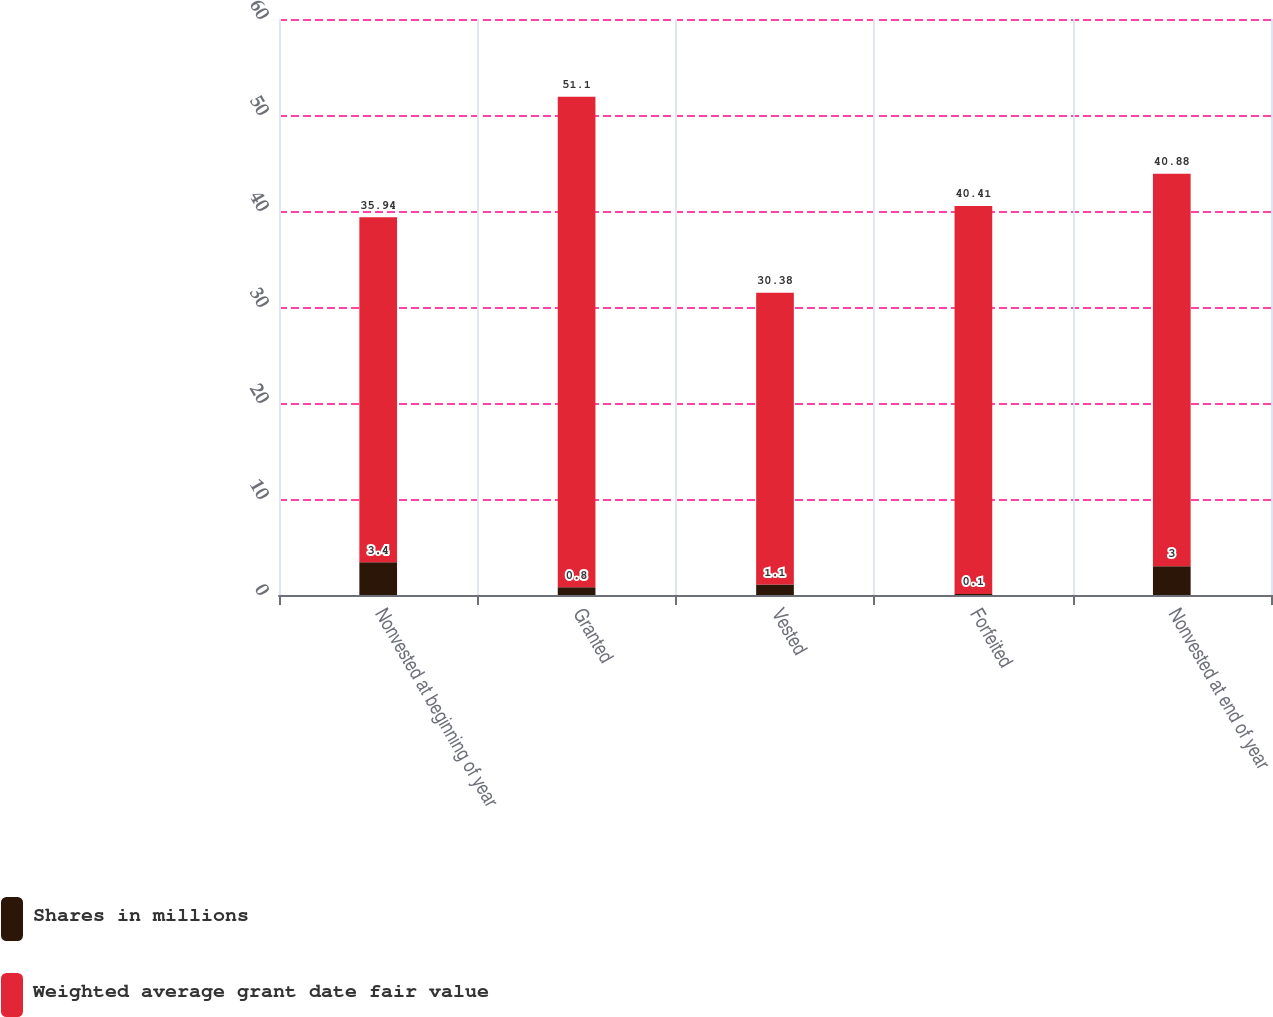<chart> <loc_0><loc_0><loc_500><loc_500><stacked_bar_chart><ecel><fcel>Nonvested at beginning of year<fcel>Granted<fcel>Vested<fcel>Forfeited<fcel>Nonvested at end of year<nl><fcel>Shares in millions<fcel>3.4<fcel>0.8<fcel>1.1<fcel>0.1<fcel>3<nl><fcel>Weighted average grant date fair value<fcel>35.94<fcel>51.1<fcel>30.38<fcel>40.41<fcel>40.88<nl></chart> 